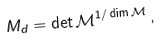Convert formula to latex. <formula><loc_0><loc_0><loc_500><loc_500>M _ { d } = \det \mathcal { M } ^ { 1 / \dim \mathcal { M } } \, ,</formula> 